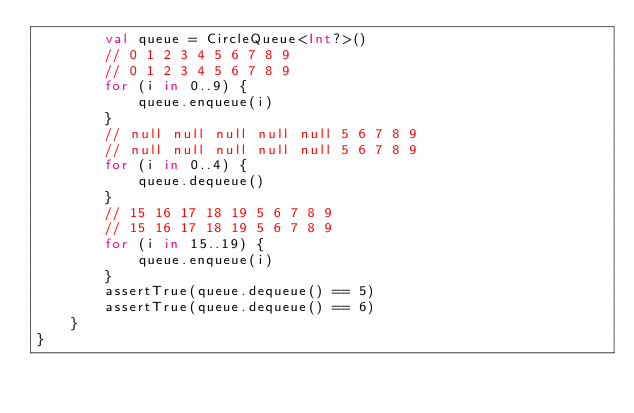Convert code to text. <code><loc_0><loc_0><loc_500><loc_500><_Kotlin_>        val queue = CircleQueue<Int?>()
        // 0 1 2 3 4 5 6 7 8 9
        // 0 1 2 3 4 5 6 7 8 9
        for (i in 0..9) {
            queue.enqueue(i)
        }
        // null null null null null 5 6 7 8 9
        // null null null null null 5 6 7 8 9
        for (i in 0..4) {
            queue.dequeue()
        }
        // 15 16 17 18 19 5 6 7 8 9
        // 15 16 17 18 19 5 6 7 8 9
        for (i in 15..19) {
            queue.enqueue(i)
        }
        assertTrue(queue.dequeue() == 5)
        assertTrue(queue.dequeue() == 6)
    }
}
</code> 